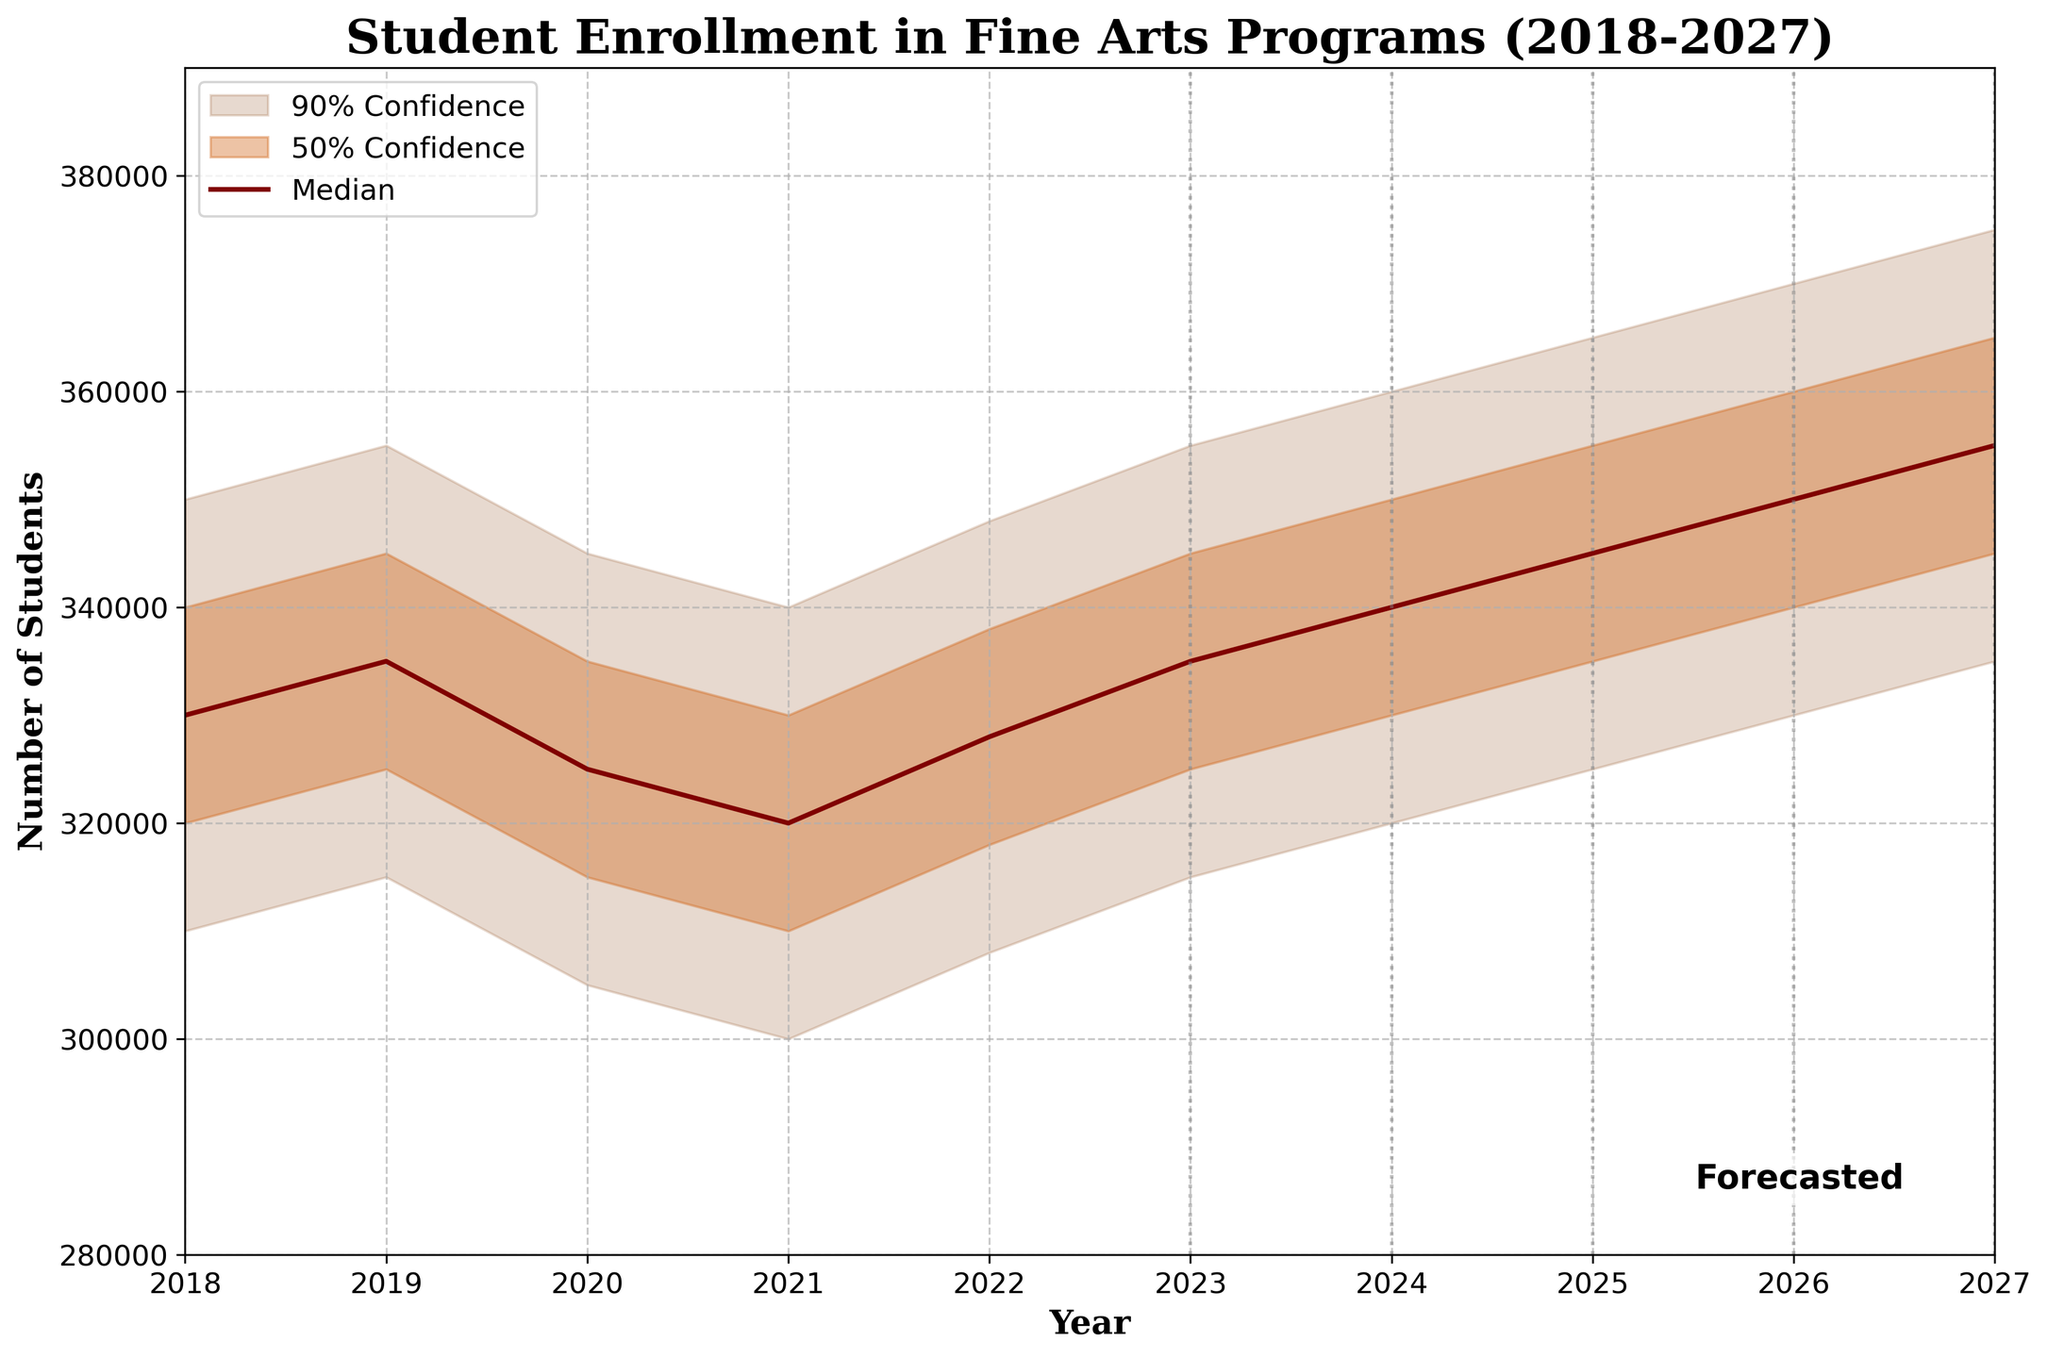What time span does the plot cover? The figure title shows the years 2018 to 2027. Both the x-axis labels and the x-limits of the plot (from 2018 to 2027) indicate the time span covered in the figure.
Answer: 2018-2027 In which year does the median student enrollment reach its maximum in the forecasted period? To find the year with the maximum median enrollment in the forecasted period, look at the median line between 2023 and 2027. The highest point on the median line at the end of this period corresponds to the year 2027.
Answer: 2027 How many student enrollment data points are plotted on the x-axis? Count the number of unique years labeled on the x-axis. The figure spans from 2018 to 2027, inclusive, making for 10 data points.
Answer: 10 Is the student enrollment trend increasing or decreasing after 2022 according to the median line? Observe the median line from 2022 through 2027. The direction of the line shows an upward trend, indicating an increase in the median student enrollment from 2022 onwards.
Answer: Increasing What is the range of student enrollments for the year 2025 within the 90% confidence interval? The 90% confidence interval is the range between the lower and upper bounds of the shaded area for each year. For 2025, the lower bound is 325,000 and the upper bound is 365,000.
Answer: 325,000-365,000 Which confidence interval range is wider for 2021 compared to 2024? Compare the 90% confidence interval for both years by looking at the space between the lower and upper bounds. For 2021, the range is from 300,000 to 340,000 (40,000), and for 2024, it is 320,000 to 360,000 (40,000). Both ranges are equal.
Answer: They are equal What is the median student enrollment in 2020? Look at the value from the median line (thickest line in the middle of the shaded areas) at the year 2020. The median value for 2020 is shown directly on the y-axis.
Answer: 325,000 By how much does the upper middle bound change from 2022 to 2023? Subtract the upper middle bound value for 2022 from the value of 2023. For 2022, it is 338,000, and for 2023, it is 345,000. Thus, 345,000 - 338,000 = 7,000.
Answer: 7,000 If the trend were to continue, what could be the potential median student enrollment around 2030? Extend the visual linear trend of the median line beyond 2027 by continuing the slope upward. Since the median approaches 355,000 in 2027, by 2030 it could be around 370,000 if the upward trend continues steadily.
Answer: Approximately 370,000 What are the minimum and maximum values of the lower bound over the entire period? To find the range of lower bounds, identify the lowest and highest points on the lower bound line from 2018 to 2027. The minimum value is 300,000 in 2021, and the maximum value is 335,000 in 2027.
Answer: 300,000-335,000 